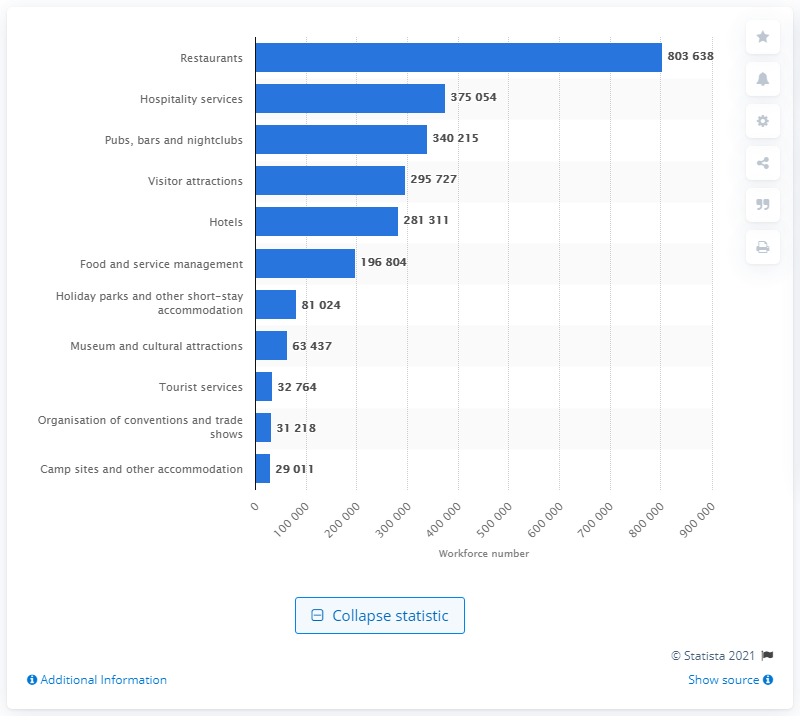Highlight a few significant elements in this photo. In 2014, a total of 281,311 individuals were employed in the hotel industry. 